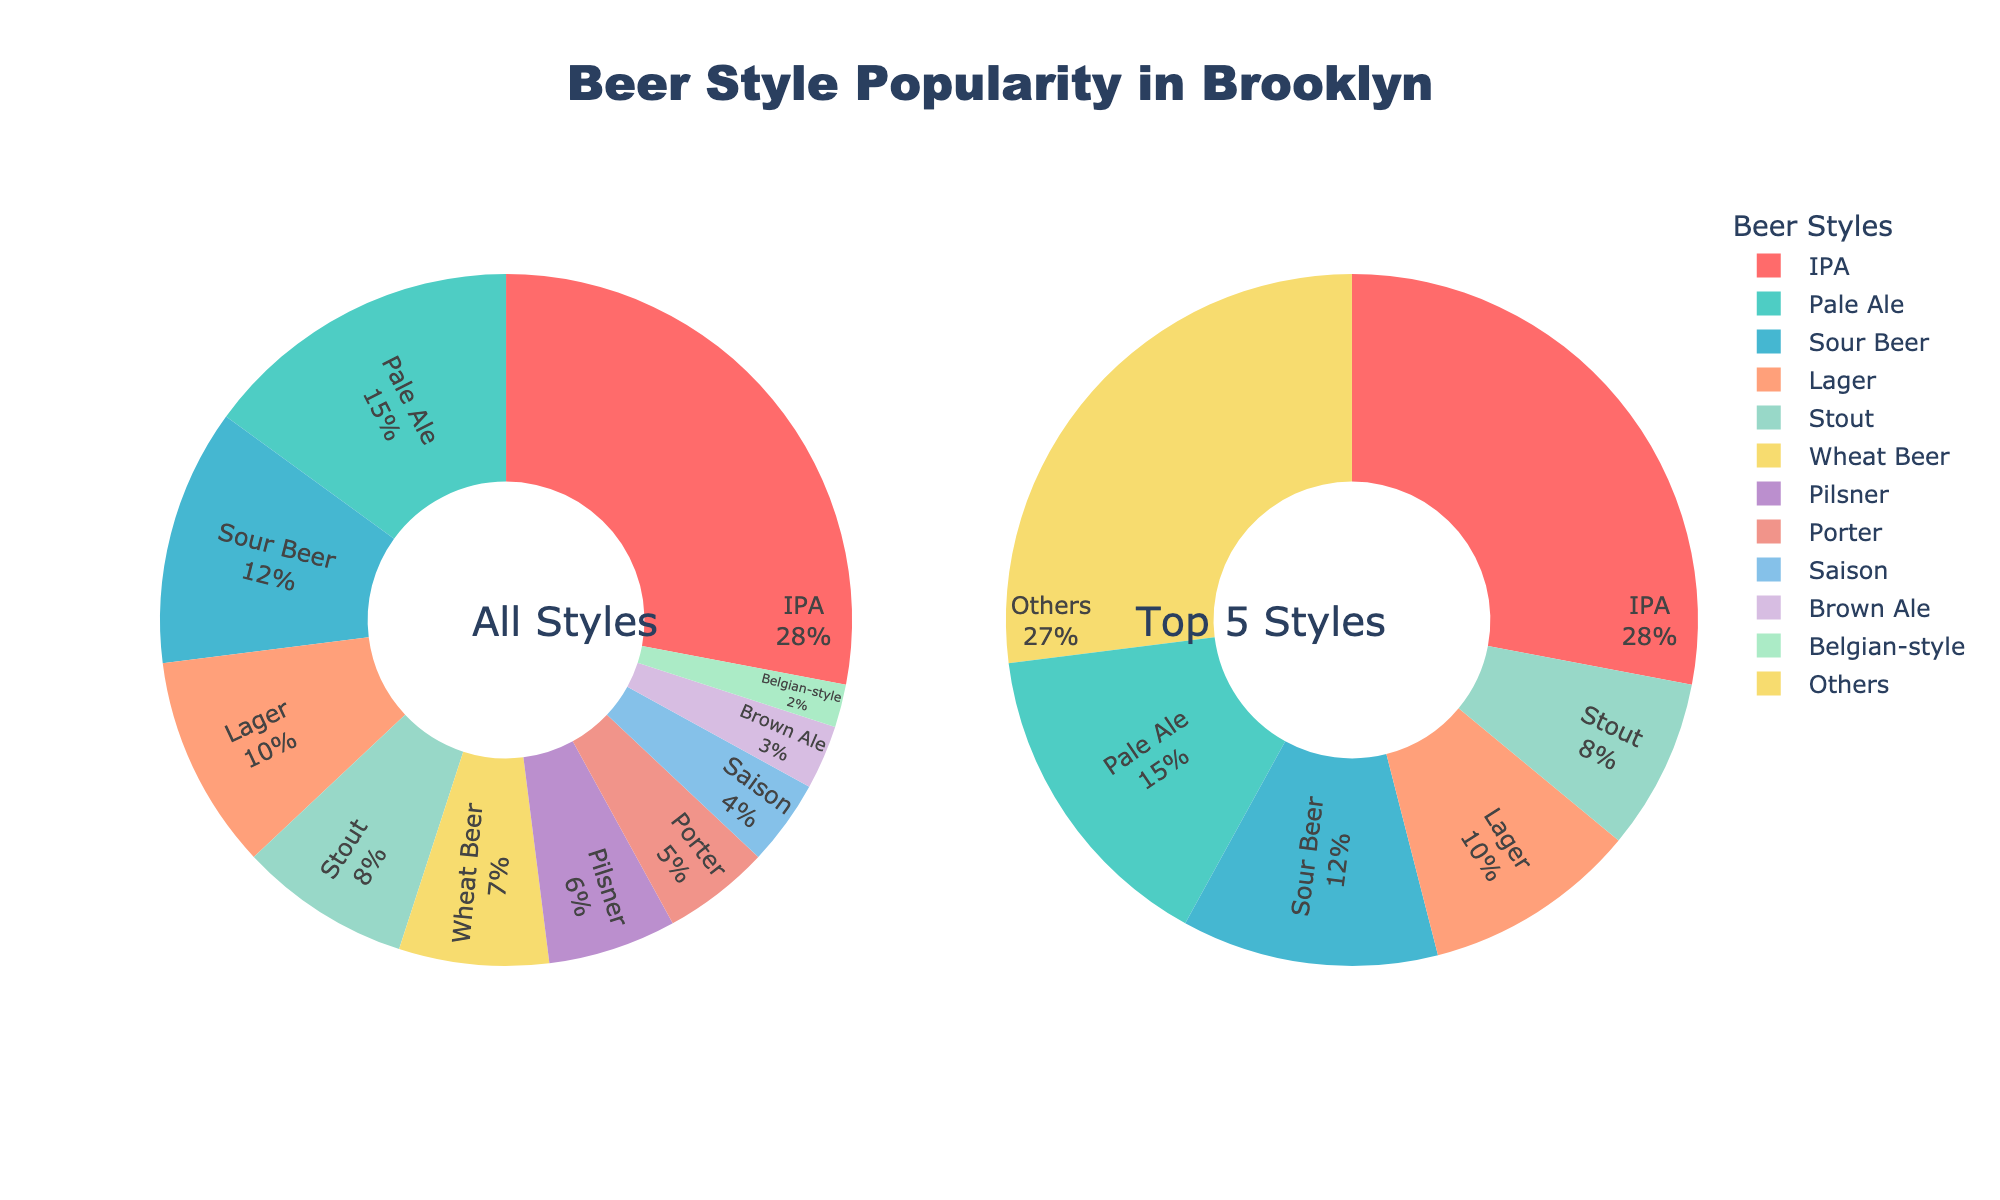Which beer style is the most popular among Brooklyn craft beer drinkers? IPA has the highest percentage at 28%, making it the most popular.
Answer: IPA What percentage of beer styles fall under "Others" in the Top 5 Styles donut chart? The percentage of "Others" is calculated by summing up the percentages of the styles ranked below the top 5, which is Lager (10%) + Stout (8%) + Wheat Beer (7%) + Pilsner (6%) + Porter (5%) + Saison (4%) + Brown Ale (3%) + Belgian-style (2%) = 45%. This 45% is combined into "Others".
Answer: 45% Which beer style ranks fifth and what percentage does it hold? The fifth most popular beer style is Stout with 8%.
Answer: Stout How does the popularity of Sour Beer compare to Pale Ale? Sour Beer has a percentage of 12%, while Pale Ale has 15%. Comparing these, Pale Ale is more popular than Sour Beer.
Answer: Pale Ale is more popular How much more popular is IPA than Lager? IPA has a percentage of 28% and Lager has 10%. The difference is calculated as 28% - 10% = 18%.
Answer: 18% Which color represents Wheat Beer, and what is its percentage? Wheat Beer is represented in yellow color and it holds 7% of the total.
Answer: Yellow, 7% What is the combined percentage of Stout and Brown Ale? Stout holds 8% and Brown Ale holds 3%, so their combined percentage is 8% + 3% = 11%.
Answer: 11% Is Pilsner more or less popular than Porter, and by how much? Pilsner has 6%, while Porter has 5%. Therefore, Pilsner is 1% more popular than Porter.
Answer: More popular by 1% What are the percentages for beer styles in the Top 5 Styles donut chart? The Top 5 beer styles and their percentages are IPA (28%), Pale Ale (15%), Sour Beer (12%), Lager (10%), and Stout (8%). Together, they sum up to a combined percentage of 28% + 15% + 12% + 10% + 8% = 73%.
Answer: 73% What visual characteristic makes it easy to distinguish the 'Top 5 Styles' from 'All Styles'? The donut chart on the right is specifically labeled "Top 5 Styles", and it includes an "Others" category, making it visually distinct.
Answer: "Top 5 Styles" label and "Others" category 